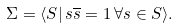Convert formula to latex. <formula><loc_0><loc_0><loc_500><loc_500>\Sigma = \langle S | \, s \overline { s } = 1 \, \forall s \in S \rangle .</formula> 